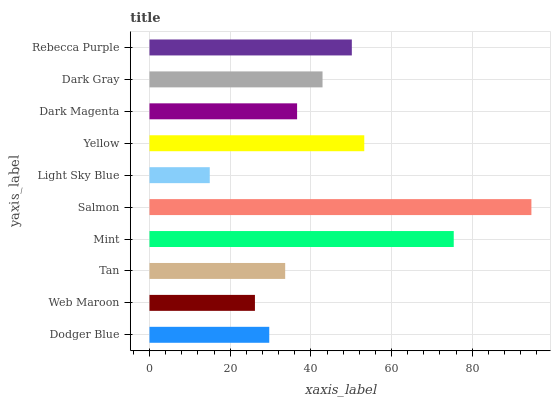Is Light Sky Blue the minimum?
Answer yes or no. Yes. Is Salmon the maximum?
Answer yes or no. Yes. Is Web Maroon the minimum?
Answer yes or no. No. Is Web Maroon the maximum?
Answer yes or no. No. Is Dodger Blue greater than Web Maroon?
Answer yes or no. Yes. Is Web Maroon less than Dodger Blue?
Answer yes or no. Yes. Is Web Maroon greater than Dodger Blue?
Answer yes or no. No. Is Dodger Blue less than Web Maroon?
Answer yes or no. No. Is Dark Gray the high median?
Answer yes or no. Yes. Is Dark Magenta the low median?
Answer yes or no. Yes. Is Mint the high median?
Answer yes or no. No. Is Web Maroon the low median?
Answer yes or no. No. 